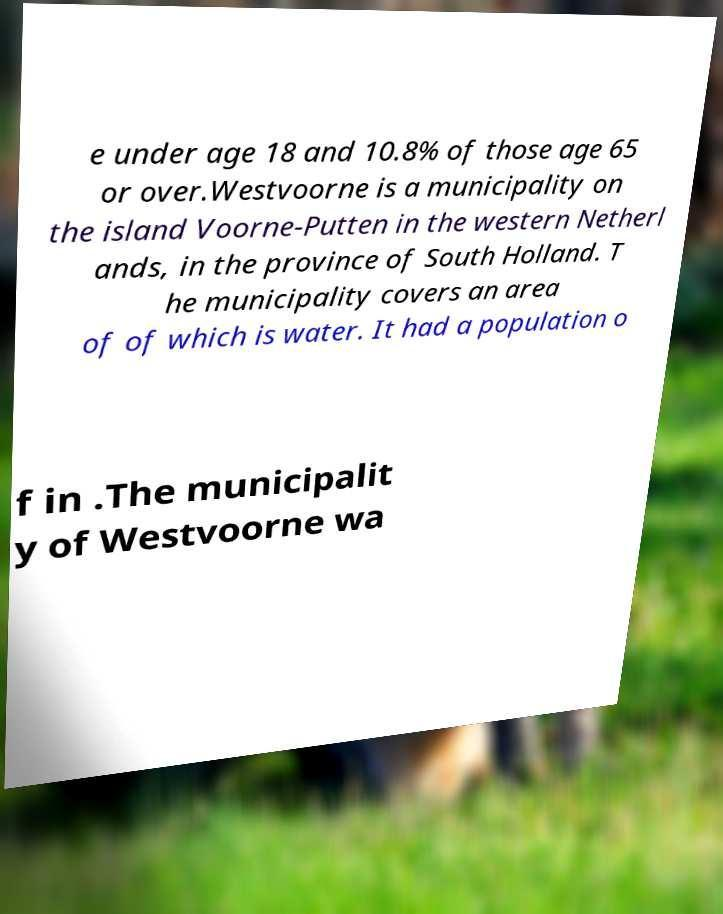Please identify and transcribe the text found in this image. e under age 18 and 10.8% of those age 65 or over.Westvoorne is a municipality on the island Voorne-Putten in the western Netherl ands, in the province of South Holland. T he municipality covers an area of of which is water. It had a population o f in .The municipalit y of Westvoorne wa 